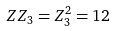Convert formula to latex. <formula><loc_0><loc_0><loc_500><loc_500>Z Z _ { 3 } = Z _ { 3 } ^ { 2 } = 1 2</formula> 